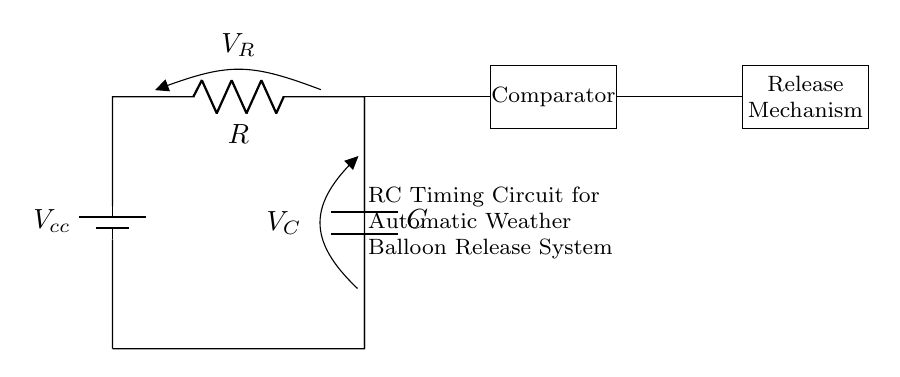What is the value of the resistor in the circuit? The circuit schematic does not specify a numerical value for resistance; it simply indicates it is labeled as R.
Answer: R What is the role of the capacitor? The capacitor stores electrical energy and is essential for the timing function in the RC timing circuit, controlling the timing for the release mechanism.
Answer: Timing function What component follows the capacitor in the circuit diagram? After the capacitor, there is a comparator connected, which is used to trigger the release mechanism based on voltage levels.
Answer: Comparator What is the purpose of the battery in this circuit? The battery provides the necessary voltage for the circuit to function, powering both the capacitor charging and comparator operations.
Answer: Power supply How does the voltage across the capacitor affect the release mechanism? As the capacitor charges, its voltage increases until it reaches a threshold set by the comparator; once this threshold is met, it activates the release mechanism.
Answer: Threshold activation What type of circuit is depicted in the diagram? The circuit is a resistor-capacitor (RC) timing circuit, used to manage time-dependent behaviors such as the delay before balloon release.
Answer: RC timing circuit What happens if the resistance is increased in this circuit? Increasing the resistance would slow down the charging of the capacitor, leading to a longer delay before the release mechanism is activated by the comparator.
Answer: Longer delay 